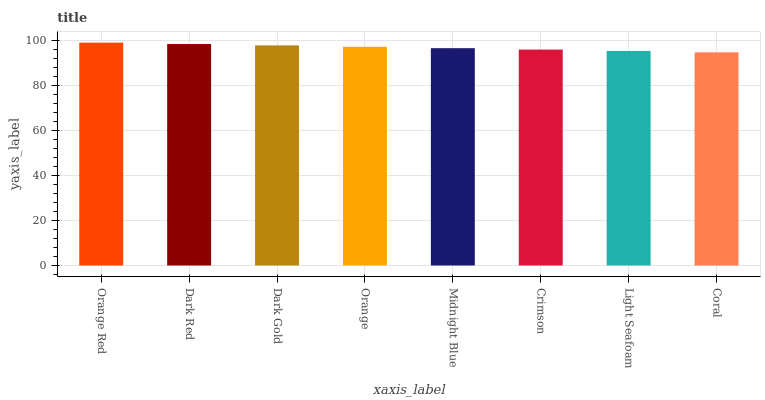Is Coral the minimum?
Answer yes or no. Yes. Is Orange Red the maximum?
Answer yes or no. Yes. Is Dark Red the minimum?
Answer yes or no. No. Is Dark Red the maximum?
Answer yes or no. No. Is Orange Red greater than Dark Red?
Answer yes or no. Yes. Is Dark Red less than Orange Red?
Answer yes or no. Yes. Is Dark Red greater than Orange Red?
Answer yes or no. No. Is Orange Red less than Dark Red?
Answer yes or no. No. Is Orange the high median?
Answer yes or no. Yes. Is Midnight Blue the low median?
Answer yes or no. Yes. Is Orange Red the high median?
Answer yes or no. No. Is Dark Gold the low median?
Answer yes or no. No. 